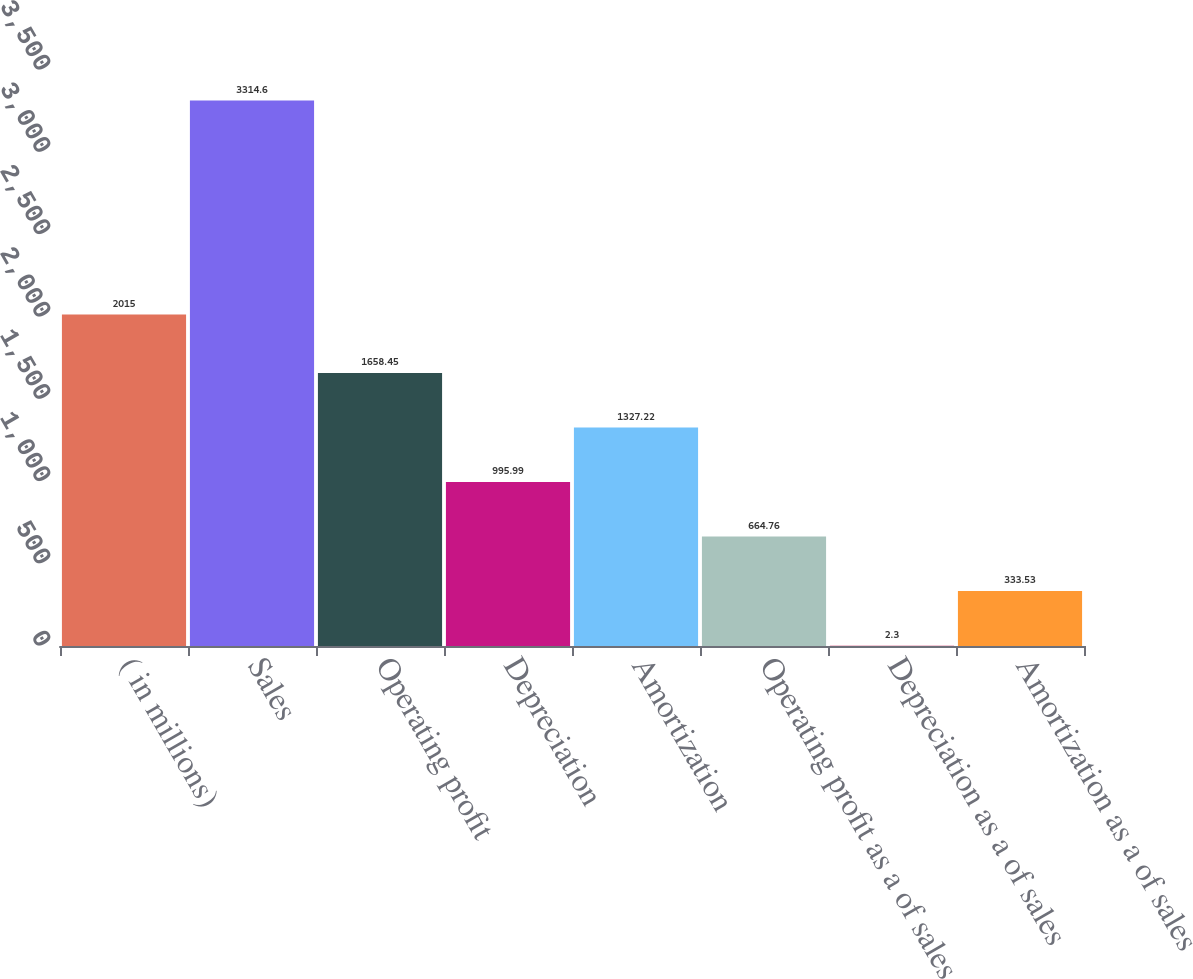Convert chart to OTSL. <chart><loc_0><loc_0><loc_500><loc_500><bar_chart><fcel>( in millions)<fcel>Sales<fcel>Operating profit<fcel>Depreciation<fcel>Amortization<fcel>Operating profit as a of sales<fcel>Depreciation as a of sales<fcel>Amortization as a of sales<nl><fcel>2015<fcel>3314.6<fcel>1658.45<fcel>995.99<fcel>1327.22<fcel>664.76<fcel>2.3<fcel>333.53<nl></chart> 